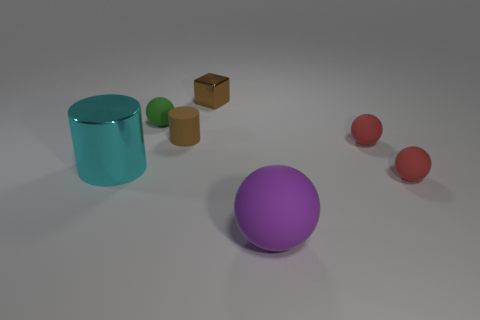Is the material of the small brown thing left of the cube the same as the brown thing that is behind the rubber cylinder?
Offer a very short reply. No. What number of objects are on the right side of the brown cylinder and in front of the brown cube?
Your answer should be very brief. 3. Is there another purple matte object of the same shape as the purple object?
Your answer should be very brief. No. There is another brown thing that is the same size as the brown metallic object; what shape is it?
Ensure brevity in your answer.  Cylinder. Is the number of small brown matte objects left of the small rubber cylinder the same as the number of green matte objects that are in front of the large metallic object?
Ensure brevity in your answer.  Yes. What is the size of the purple thing in front of the big thing that is to the left of the purple rubber ball?
Make the answer very short. Large. Are there any cubes of the same size as the cyan metal thing?
Provide a short and direct response. No. There is a small object that is made of the same material as the big cylinder; what is its color?
Provide a short and direct response. Brown. Is the number of large cyan cylinders less than the number of small red balls?
Ensure brevity in your answer.  Yes. There is a thing that is both behind the big cyan metal object and right of the block; what is it made of?
Your response must be concise. Rubber. 